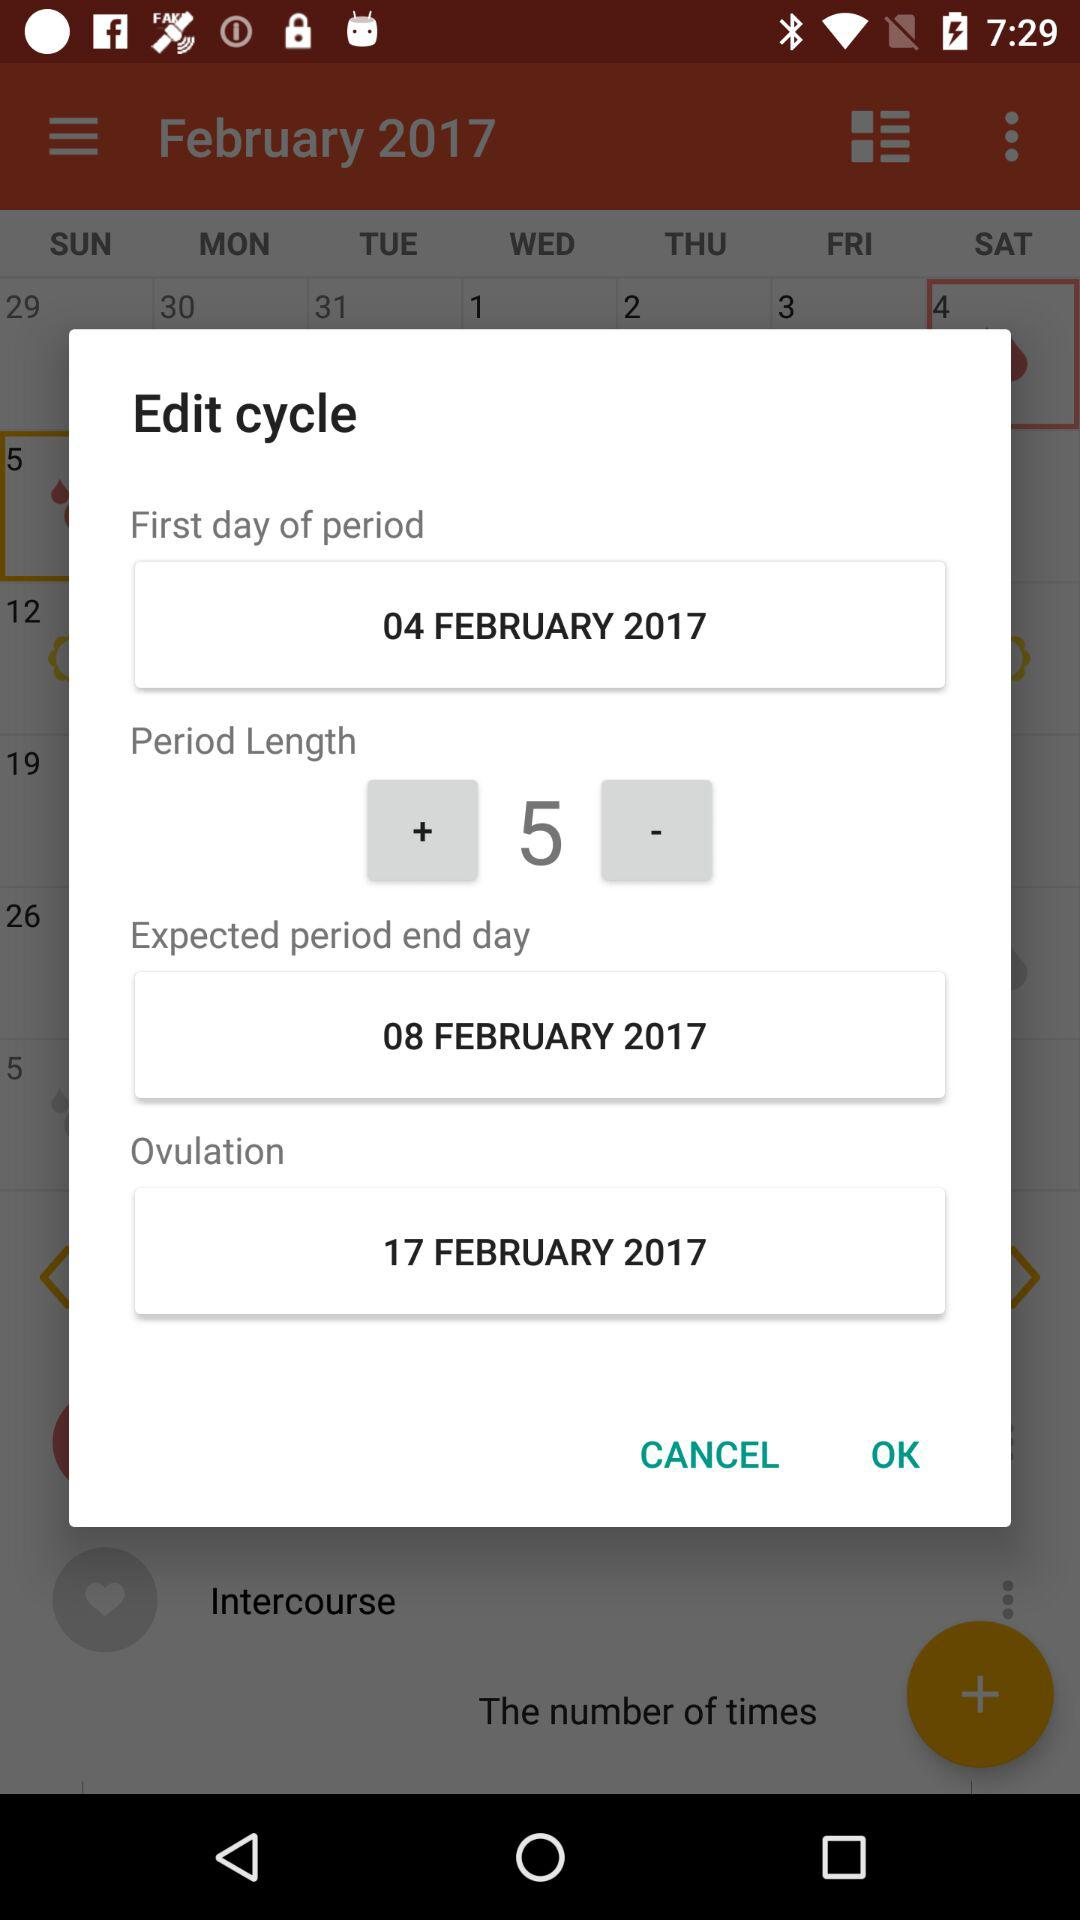What is the date of the first day of the period? The date of the first day of the period is February 4, 2017. 